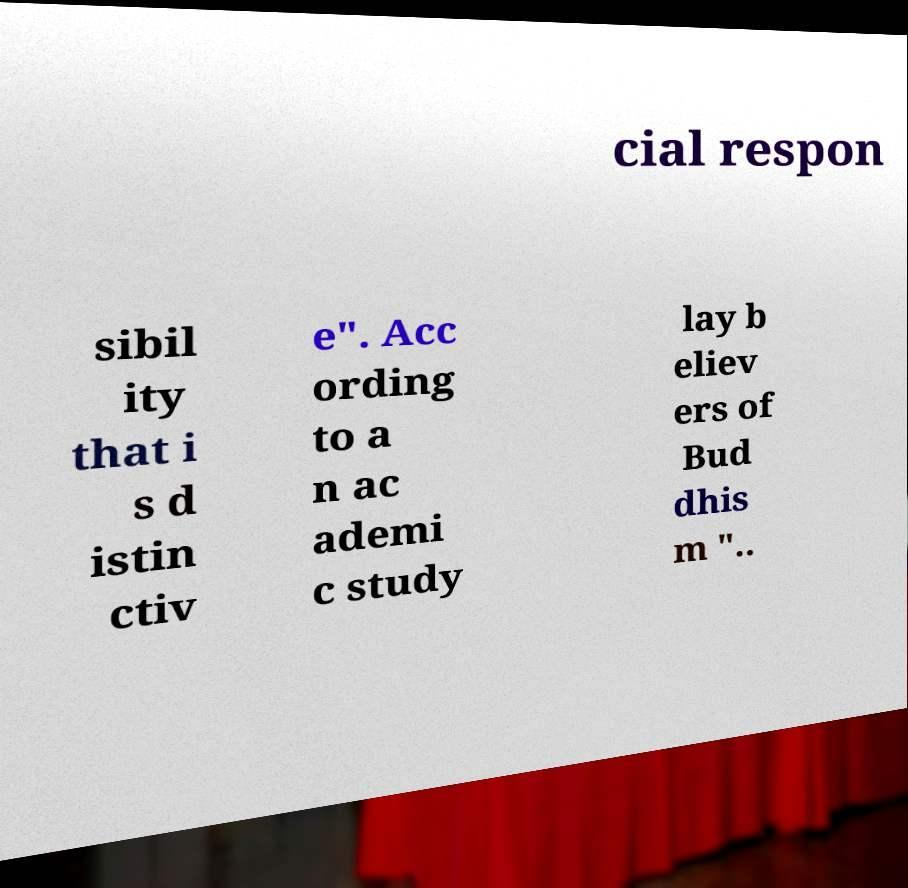Please read and relay the text visible in this image. What does it say? cial respon sibil ity that i s d istin ctiv e". Acc ording to a n ac ademi c study lay b eliev ers of Bud dhis m ".. 